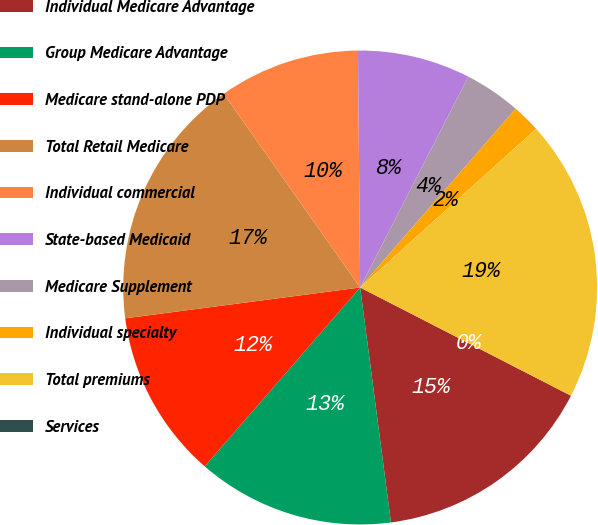<chart> <loc_0><loc_0><loc_500><loc_500><pie_chart><fcel>Individual Medicare Advantage<fcel>Group Medicare Advantage<fcel>Medicare stand-alone PDP<fcel>Total Retail Medicare<fcel>Individual commercial<fcel>State-based Medicaid<fcel>Medicare Supplement<fcel>Individual specialty<fcel>Total premiums<fcel>Services<nl><fcel>15.38%<fcel>13.46%<fcel>11.54%<fcel>17.31%<fcel>9.62%<fcel>7.69%<fcel>3.85%<fcel>1.93%<fcel>19.23%<fcel>0.0%<nl></chart> 